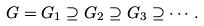<formula> <loc_0><loc_0><loc_500><loc_500>G = G _ { 1 } \supseteq G _ { 2 } \supseteq G _ { 3 } \supseteq \cdots .</formula> 